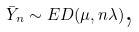Convert formula to latex. <formula><loc_0><loc_0><loc_500><loc_500>\bar { Y } _ { n } \sim E D ( \mu , n \lambda ) \text {,}</formula> 